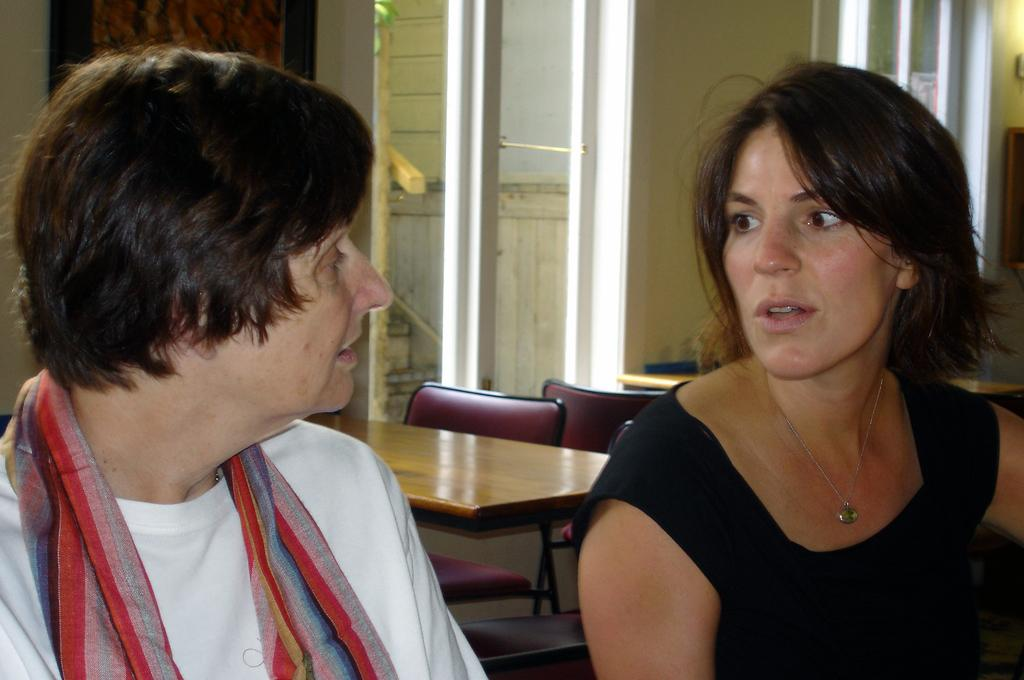How many people are present in the image? There are two people, a man and a woman, present in the image. What are the man and woman doing in the image? The man and woman are sitting. What can be seen in the background of the image? There is a table, a hair, and a window in the background of the image. What type of button is being advertised in the image? There is no button or advertisement present in the image. What advice does the grandfather give to the man and woman in the image? There is no grandfather present in the image, so no advice can be given. 